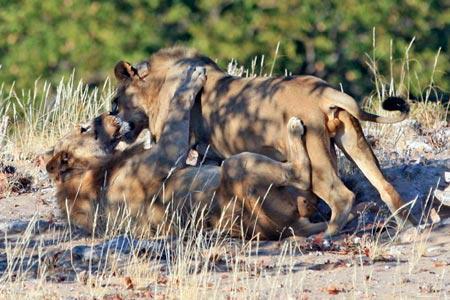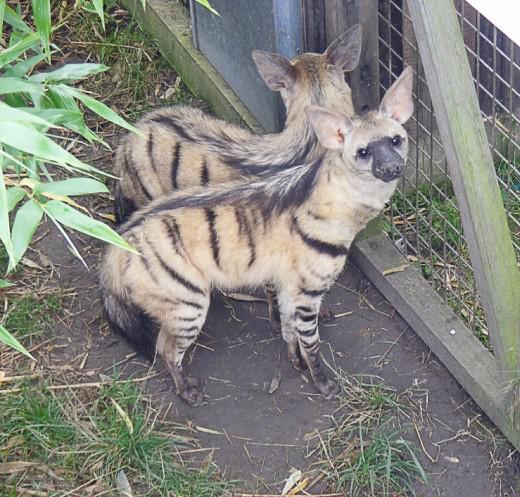The first image is the image on the left, the second image is the image on the right. For the images displayed, is the sentence "Each image contains exactly one canine-type animal, and the animals on the left and right have the same kind of fur markings." factually correct? Answer yes or no. No. The first image is the image on the left, the second image is the image on the right. Evaluate the accuracy of this statement regarding the images: "The left and right image contains the same number of hyenas with at least one being striped.". Is it true? Answer yes or no. No. 